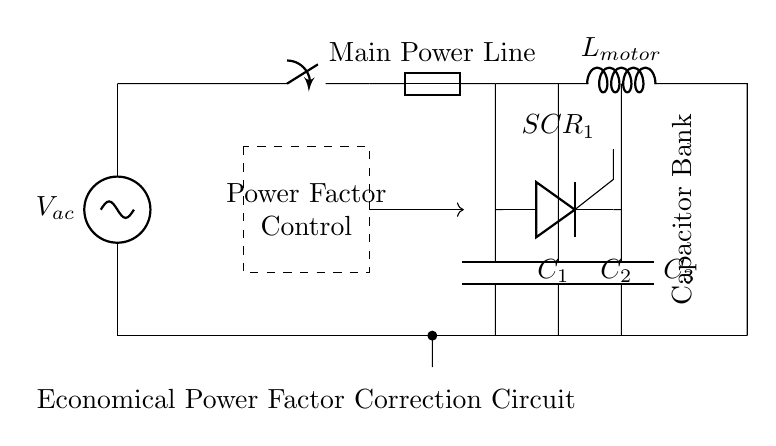what type of load is represented in this circuit? The load in this circuit is represented as an inductor, specifically labeled as L_motor. This indicates that the appliance primarily relies on inductive components, typical for high power devices like washing machine motors.
Answer: Inductive what is the purpose of the capacitor bank in this circuit? The capacitor bank is used for power factor correction. It helps to compensate for the lagging power factor caused by the inductive load, improving the overall efficiency of the circuit and reducing the demand on the power source.
Answer: Power factor correction how many capacitors are present in the circuit? There are three capacitors present in the circuit, labeled as C_1, C_2, and C_3. Each capacitor plays a role in improving the power factor by providing leading reactive power to counteract the lagging effect of the motor.
Answer: Three what device is used to control the capacitor bank in this circuit? The device used to control the capacitor bank is a thyristor, specifically SCR_1. This component allows for the regulation of the capacitors' connection to the circuit, enabling dynamic adjustment of power factor correction as needed.
Answer: Thyristor what component protects the circuit from overload? The component that protects the circuit from overload is the fuse. It is designed to disconnect the circuit in case of excessive current flow, preventing damage to the circuit components.
Answer: Fuse how does the control circuit affect the operation of the capacitor bank? The control circuit manages the operation of the thyristor switch (SCR_1) that connects or disconnects the capacitor bank as required based on the power factor. This allows the circuit to dynamically adjust the capacitive compensation, optimizing performance under varying load conditions.
Answer: Dynamic adjustment 